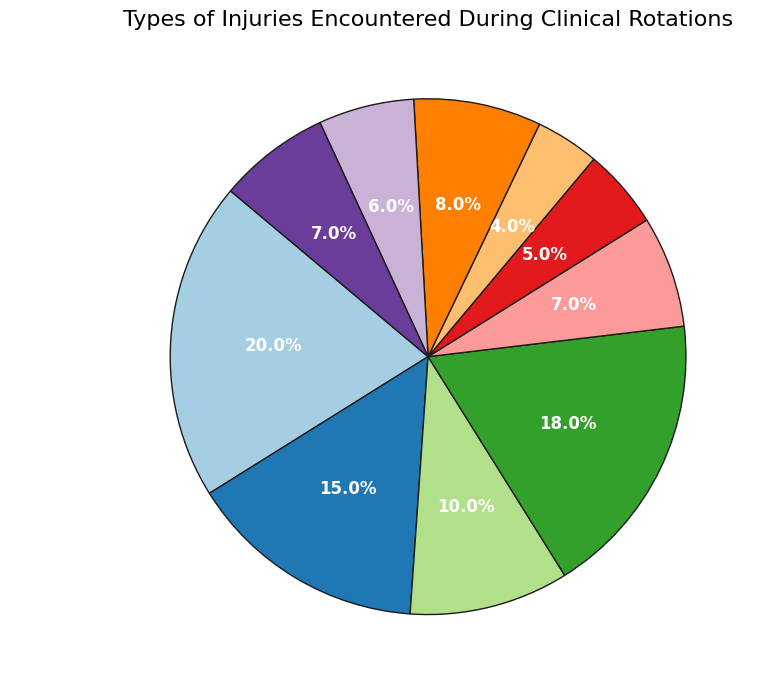What's the most common type of injury? Look at the pie chart and identify the segment with the largest percentage. 'Sprains and Strains' is the largest with 20%.
Answer: Sprains and Strains Which type of injury is more common, burns or back injuries? Compare the segments for 'Burns' and 'Back Injuries'. Burns have a percentage of 7%, while Back Injuries have a percentage of 6%.
Answer: Burns What is the combined percentage of fractures and dislocations? Add the percentages of 'Fractures' (15%) and 'Dislocations' (5%). The combined percentage is 15% + 5%.
Answer: 20% Which injury type has the smallest percentage? Identify the smallest segment in the pie chart. 'Puncture Wounds' has the smallest percentage at 4%.
Answer: Puncture Wounds Are lacerations more common than head injuries? Compare the segments for 'Lacerations' and 'Head Injuries'. Lacerations have 10%, while Head Injuries have 8%.
Answer: Yes What is the average percentage of burns, back injuries, and other? Add the percentages of 'Burns' (7%), 'Back Injuries' (6%), and 'Other' (7%) and then divide by 3. The calculation is (7 + 6 + 7) / 3.
Answer: 6.67% How much larger is the percentage of contusions compared to puncture wounds? Subtract the percentage of 'Puncture Wounds' (4%) from 'Contusions' (18%). The calculation is 18% - 4%.
Answer: 14% Which two types of injuries have the same percentage? Identify segments with the same percentage. Both 'Burns' and 'Other' have 7%.
Answer: Burns and Other What percentage of injuries are either lacerations or sprains and strains? Add the percentages of 'Lacerations' (10%) and 'Sprains and Strains' (20%). The combined percentage is 10% + 20%.
Answer: 30% How does the percentage of head injuries compare to that of dislocations? Compare the segments for 'Head Injuries' (8%) and 'Dislocations' (5%). Head Injuries are larger.
Answer: Head Injuries are larger 